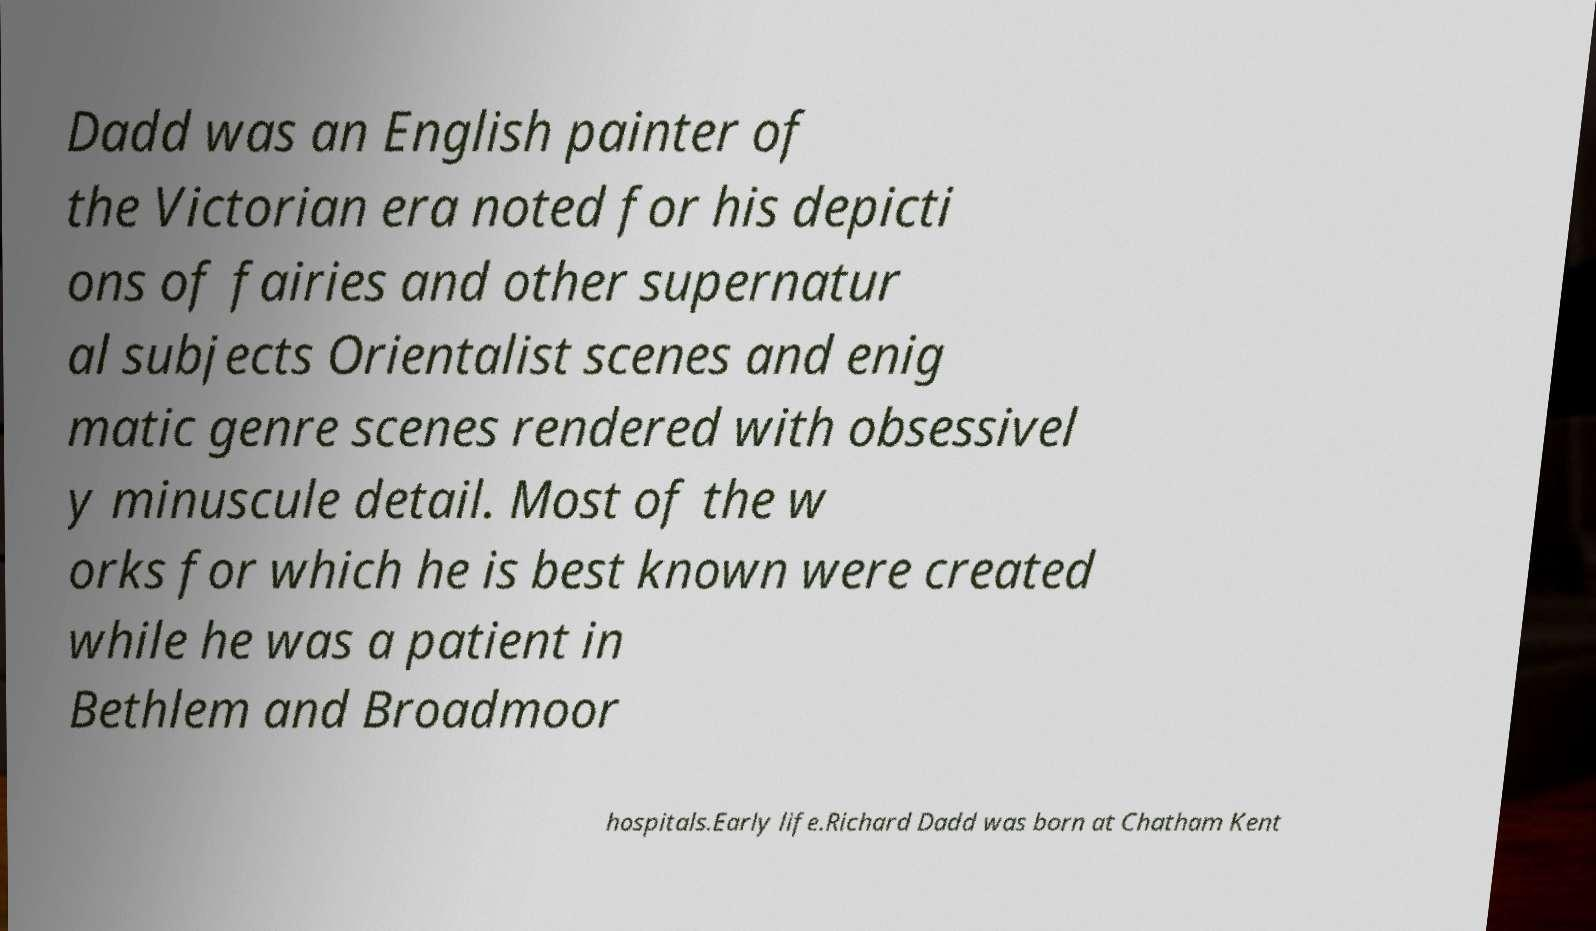I need the written content from this picture converted into text. Can you do that? Dadd was an English painter of the Victorian era noted for his depicti ons of fairies and other supernatur al subjects Orientalist scenes and enig matic genre scenes rendered with obsessivel y minuscule detail. Most of the w orks for which he is best known were created while he was a patient in Bethlem and Broadmoor hospitals.Early life.Richard Dadd was born at Chatham Kent 